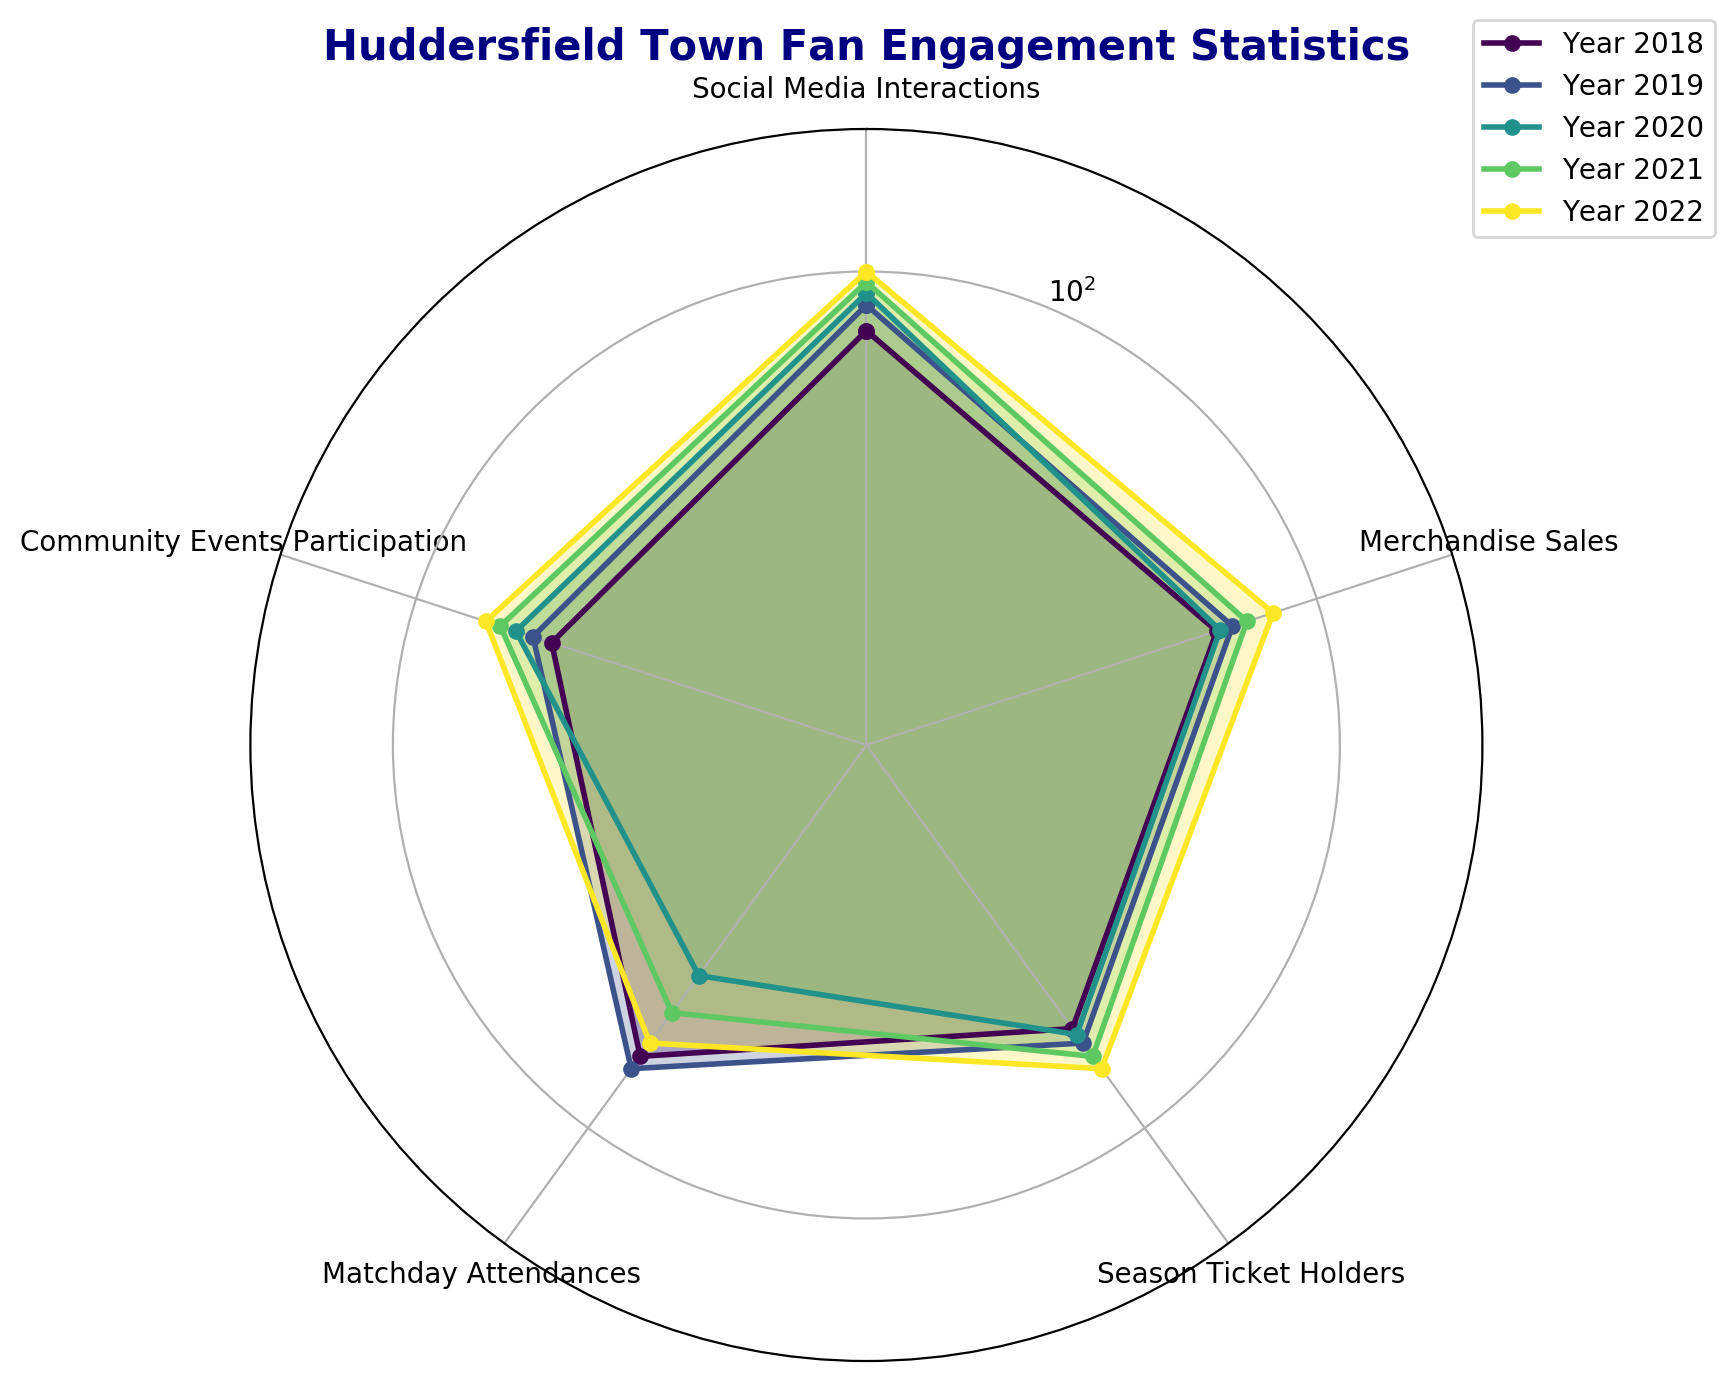Which year had the highest social media interactions? From the radar chart, the year with the highest value in the "Social Media Interactions" parameter reaches the outermost edge. In this case, it's 2022.
Answer: 2022 Which parameter saw the biggest improvement from 2018 to 2022? By comparing the difference for each parameter between 2018 and 2022, "Social Media Interactions" increased from 75 to 100, which is the largest improvement.
Answer: Social Media Interactions In which year did community events participation surpass matchday attendances? In 2020 and 2021, the radar chart shows "Community Events Participation" values exceeding those of "Matchday Attendances."
Answer: 2020, 2021 What is the average value of "Season Ticket Holders" across all years? The "Season Ticket Holders" values over the years are 55, 60, 57, 65, and 70. Sum these up to get 55 + 60 + 57 + 65 + 70 = 307, then divide by 5 to get the average.
Answer: 61.4 Which year had the lowest matchday attendances? The year with the smallest "Matchday Attendances" value on the radar chart is 2020, which has the shortest radius in the corresponding category.
Answer: 2020 